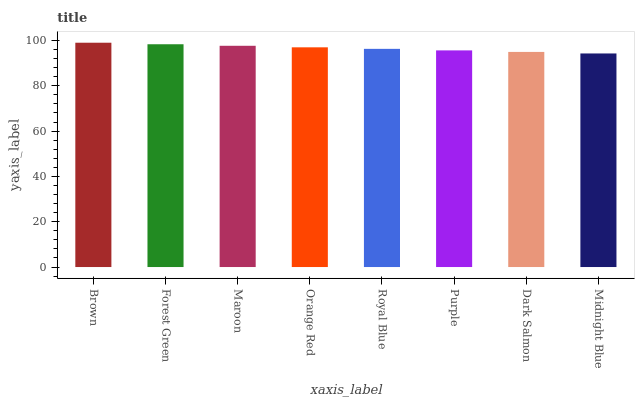Is Midnight Blue the minimum?
Answer yes or no. Yes. Is Brown the maximum?
Answer yes or no. Yes. Is Forest Green the minimum?
Answer yes or no. No. Is Forest Green the maximum?
Answer yes or no. No. Is Brown greater than Forest Green?
Answer yes or no. Yes. Is Forest Green less than Brown?
Answer yes or no. Yes. Is Forest Green greater than Brown?
Answer yes or no. No. Is Brown less than Forest Green?
Answer yes or no. No. Is Orange Red the high median?
Answer yes or no. Yes. Is Royal Blue the low median?
Answer yes or no. Yes. Is Maroon the high median?
Answer yes or no. No. Is Dark Salmon the low median?
Answer yes or no. No. 